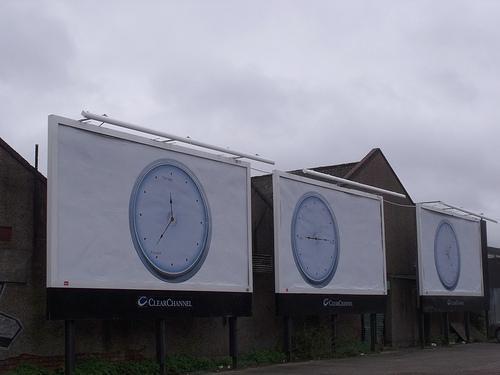How many people are in the picture?
Give a very brief answer. 0. How many clocks are in the picture?
Give a very brief answer. 3. How many posts are there?
Give a very brief answer. 3. How many clocks are there?
Give a very brief answer. 3. How many hands are on the clock faces?
Give a very brief answer. 2. How many billboards are there?
Give a very brief answer. 3. 